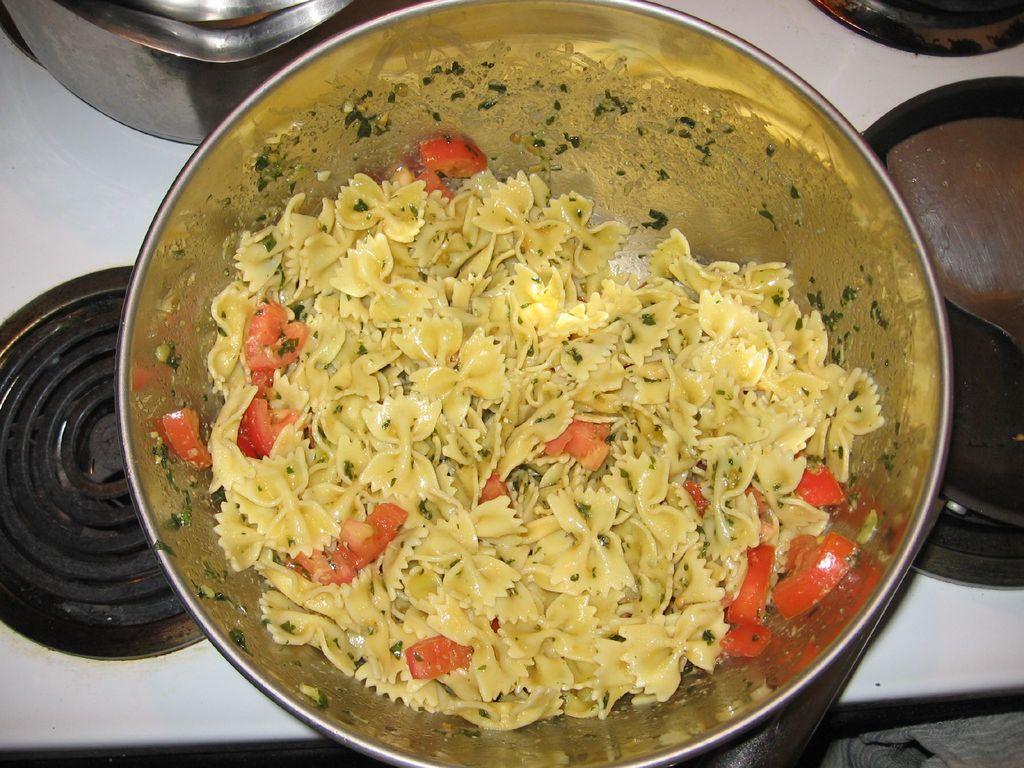Please provide a concise description of this image. In a given image i can see a bowl filled with food item. 